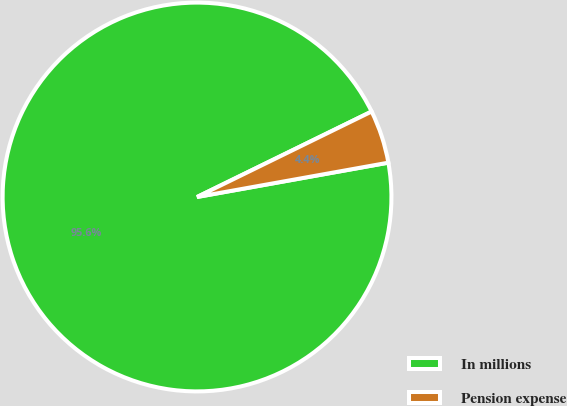Convert chart to OTSL. <chart><loc_0><loc_0><loc_500><loc_500><pie_chart><fcel>In millions<fcel>Pension expense<nl><fcel>95.58%<fcel>4.42%<nl></chart> 